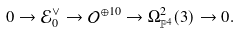Convert formula to latex. <formula><loc_0><loc_0><loc_500><loc_500>0 \to \mathcal { E } _ { 0 } ^ { \vee } \to \mathcal { O } ^ { \oplus 1 0 } \to \Omega _ { \mathbb { P } ^ { 4 } } ^ { 2 } ( 3 ) \to 0 .</formula> 